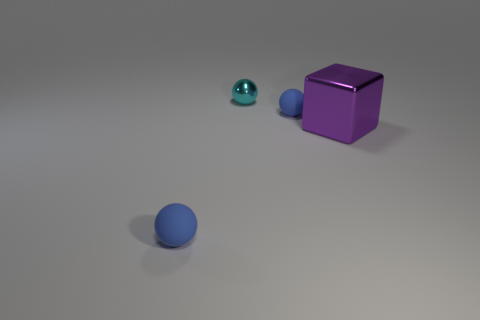Is there anything else that has the same size as the shiny cube?
Ensure brevity in your answer.  No. How many other objects are the same size as the purple object?
Your answer should be very brief. 0. There is a rubber ball that is in front of the purple thing; what is its size?
Your answer should be compact. Small. How many tiny blue spheres have the same material as the cyan sphere?
Ensure brevity in your answer.  0. There is a metal thing that is to the left of the block; is it the same shape as the big metallic object?
Ensure brevity in your answer.  No. There is a blue rubber thing in front of the shiny cube; what shape is it?
Make the answer very short. Sphere. What material is the large purple thing?
Keep it short and to the point. Metal. Is the shape of the cyan shiny object the same as the big purple shiny thing?
Give a very brief answer. No. There is a thing that is both to the right of the small metal thing and left of the large purple shiny thing; what is it made of?
Ensure brevity in your answer.  Rubber. What size is the purple metal object?
Your answer should be compact. Large. 